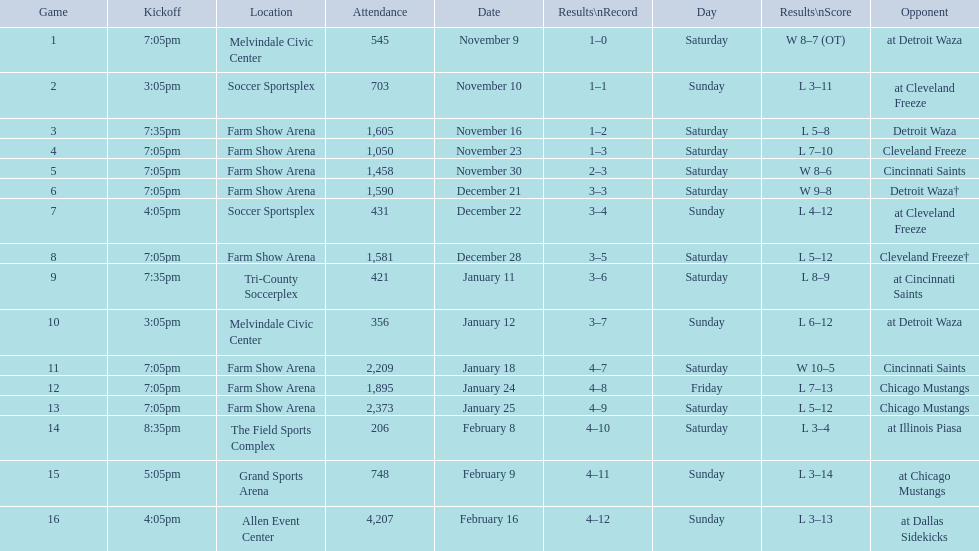What is the total number of games the harrisburg heat lost to the cleveland freeze? 4. 